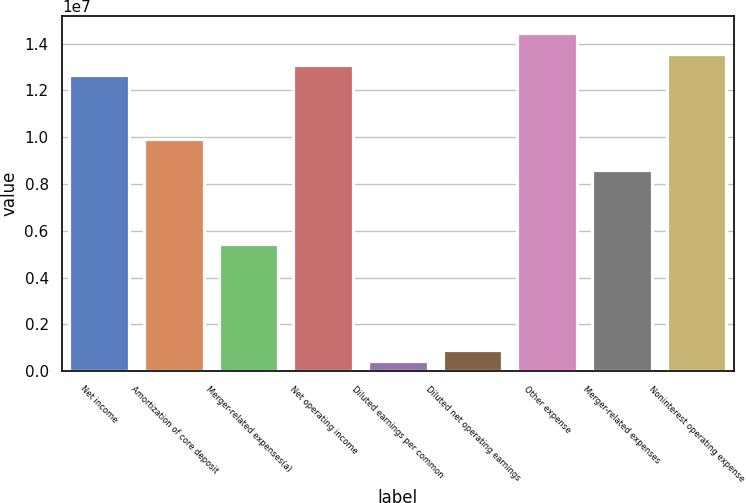Convert chart. <chart><loc_0><loc_0><loc_500><loc_500><bar_chart><fcel>Net income<fcel>Amortization of core deposit<fcel>Merger-related expenses(a)<fcel>Net operating income<fcel>Diluted earnings per common<fcel>Diluted net operating earnings<fcel>Other expense<fcel>Merger-related expenses<fcel>Noninterest operating expense<nl><fcel>1.26469e+07<fcel>9.93684e+06<fcel>5.4201e+06<fcel>1.30986e+07<fcel>451678<fcel>903352<fcel>1.44536e+07<fcel>8.58182e+06<fcel>1.35502e+07<nl></chart> 